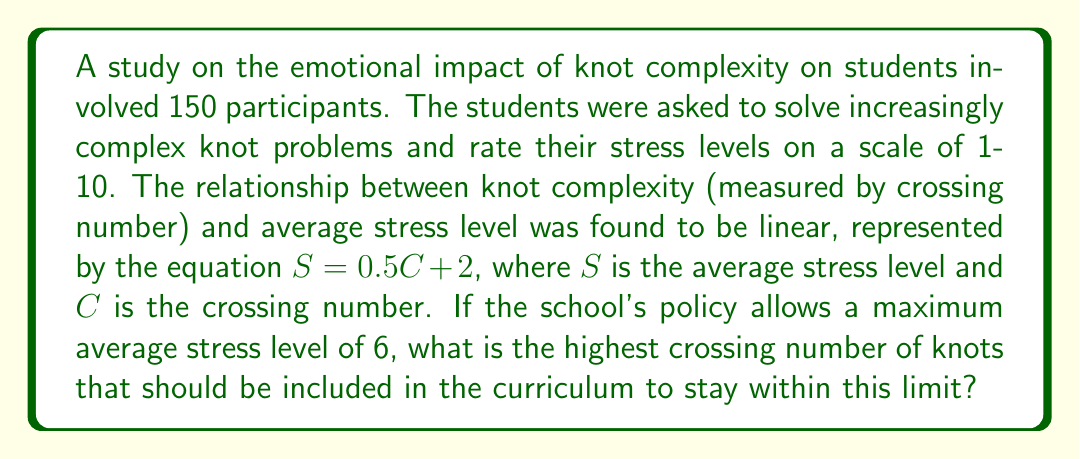Can you answer this question? Let's approach this step-by-step:

1) We are given the linear equation: $S = 0.5C + 2$
   Where $S$ is the average stress level and $C$ is the crossing number.

2) We need to find the maximum value of $C$ when $S = 6$ (the maximum allowed average stress level).

3) Let's substitute $S = 6$ into our equation:
   $6 = 0.5C + 2$

4) Now, let's solve for $C$:
   $6 - 2 = 0.5C$
   $4 = 0.5C$

5) Multiply both sides by 2:
   $8 = C$

6) Therefore, the highest crossing number that keeps the average stress level at or below 6 is 8.

7) However, since crossing numbers are always integers, and we're looking for the highest number that doesn't exceed our limit, we need to check if this result actually keeps us within the limit:

   If $C = 8$, then $S = 0.5(8) + 2 = 6$

   This confirms that a crossing number of 8 is indeed the highest that keeps us within the stress limit.
Answer: 8 